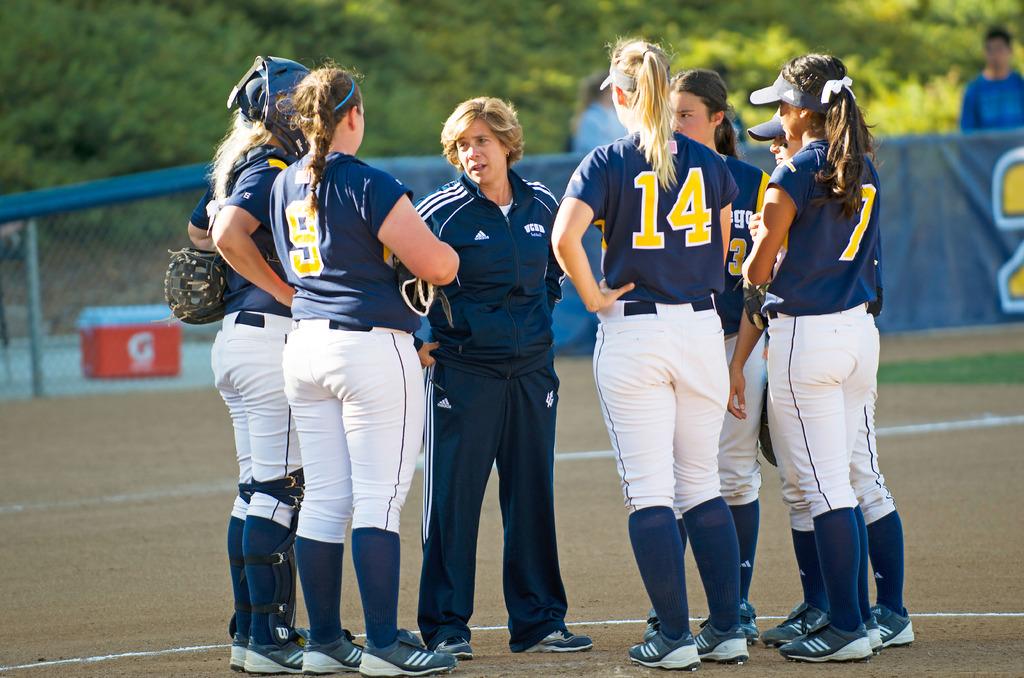What number is the right on the left?
Keep it short and to the point. 9. What is the number of the player on the right?
Provide a succinct answer. 7. 